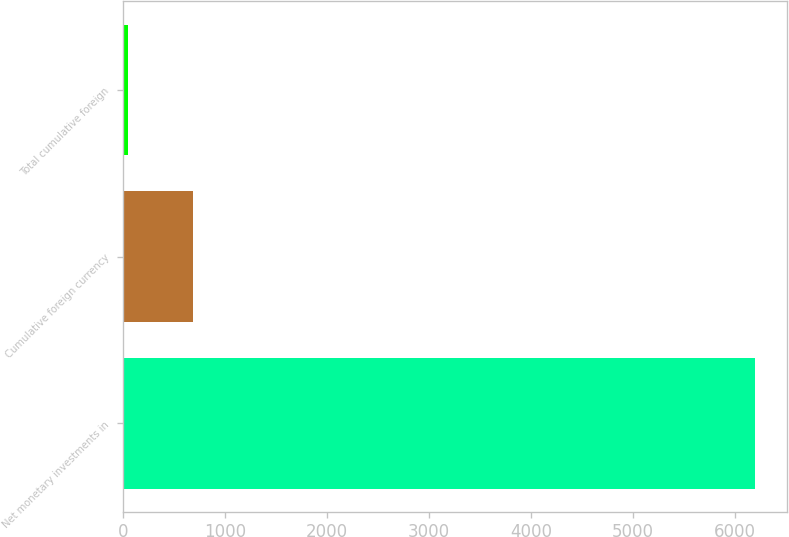Convert chart to OTSL. <chart><loc_0><loc_0><loc_500><loc_500><bar_chart><fcel>Net monetary investments in<fcel>Cumulative foreign currency<fcel>Total cumulative foreign<nl><fcel>6195<fcel>692<fcel>49<nl></chart> 